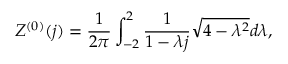<formula> <loc_0><loc_0><loc_500><loc_500>Z ^ { ( 0 ) } ( j ) = \frac { 1 } { 2 \pi } \int _ { - 2 } ^ { 2 } \frac { 1 } { 1 - \lambda j } \sqrt { 4 - \lambda ^ { 2 } } d \lambda ,</formula> 